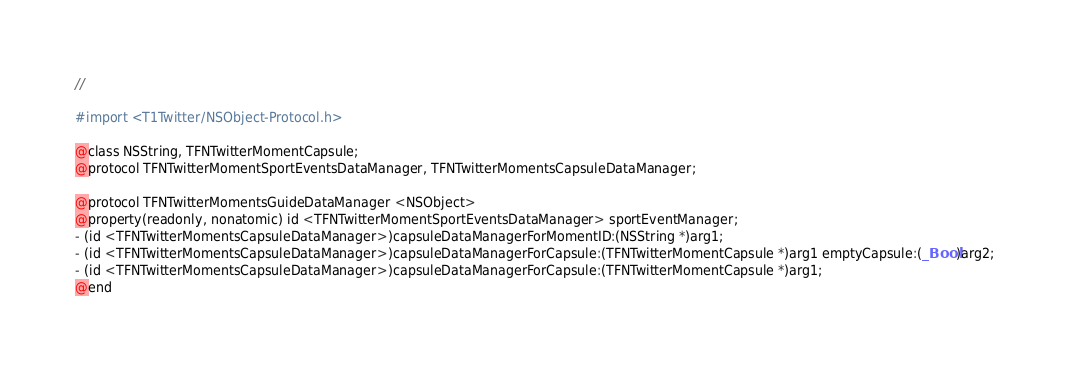Convert code to text. <code><loc_0><loc_0><loc_500><loc_500><_C_>//

#import <T1Twitter/NSObject-Protocol.h>

@class NSString, TFNTwitterMomentCapsule;
@protocol TFNTwitterMomentSportEventsDataManager, TFNTwitterMomentsCapsuleDataManager;

@protocol TFNTwitterMomentsGuideDataManager <NSObject>
@property(readonly, nonatomic) id <TFNTwitterMomentSportEventsDataManager> sportEventManager;
- (id <TFNTwitterMomentsCapsuleDataManager>)capsuleDataManagerForMomentID:(NSString *)arg1;
- (id <TFNTwitterMomentsCapsuleDataManager>)capsuleDataManagerForCapsule:(TFNTwitterMomentCapsule *)arg1 emptyCapsule:(_Bool)arg2;
- (id <TFNTwitterMomentsCapsuleDataManager>)capsuleDataManagerForCapsule:(TFNTwitterMomentCapsule *)arg1;
@end

</code> 